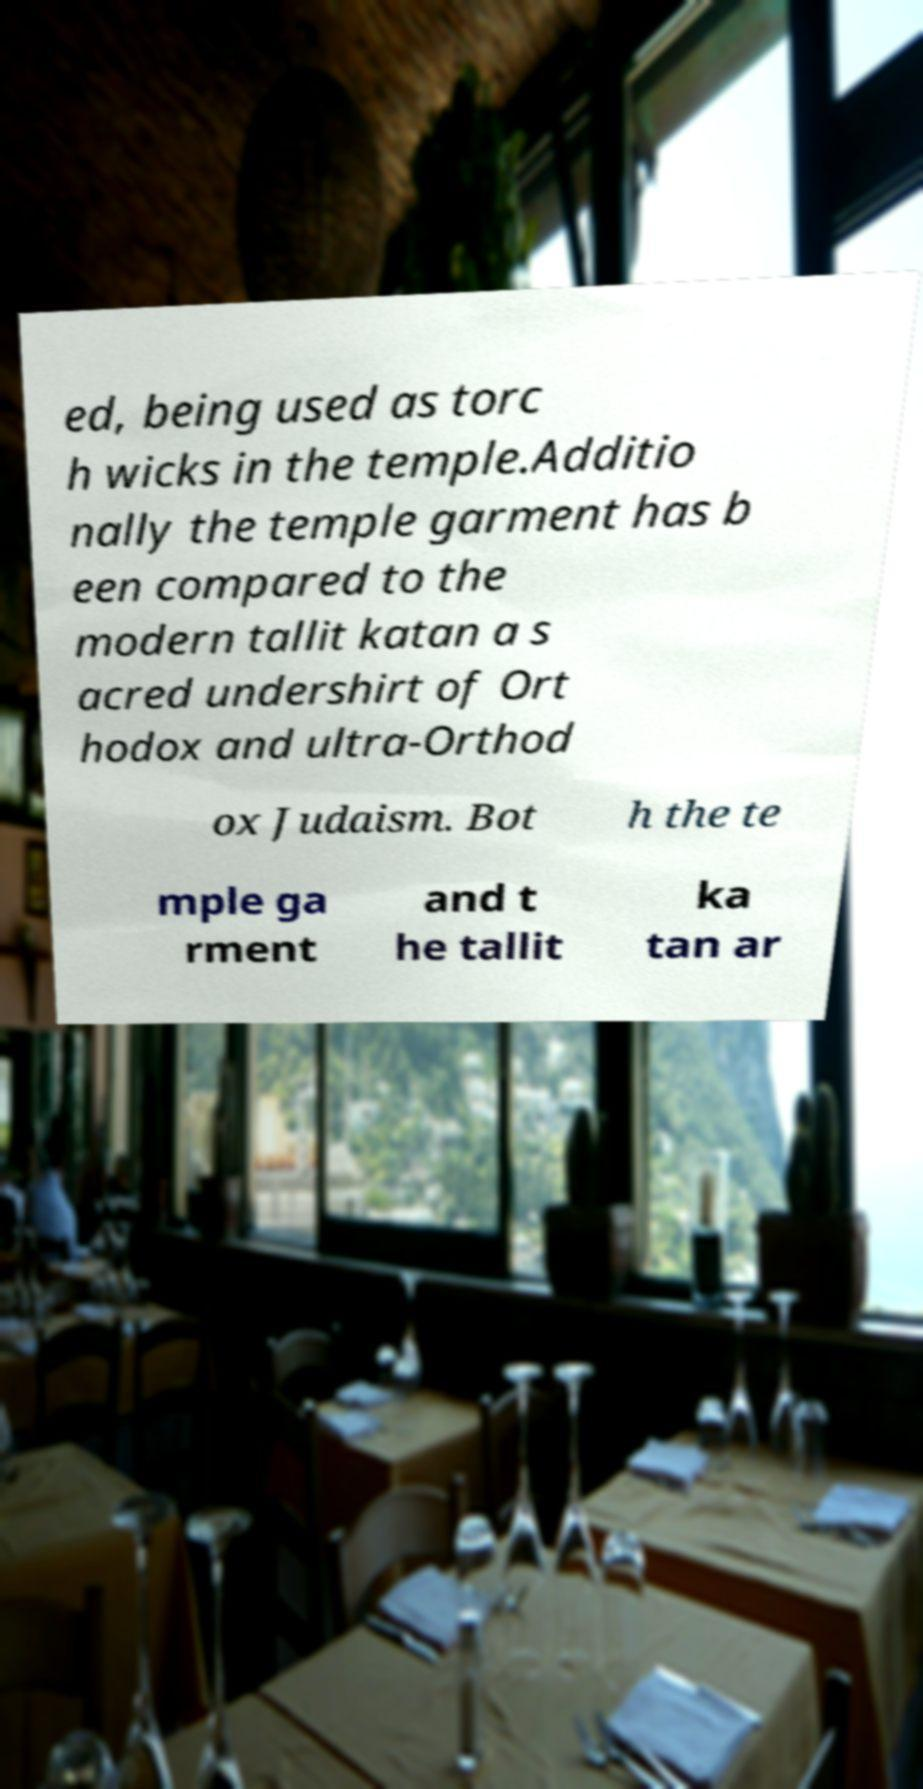There's text embedded in this image that I need extracted. Can you transcribe it verbatim? ed, being used as torc h wicks in the temple.Additio nally the temple garment has b een compared to the modern tallit katan a s acred undershirt of Ort hodox and ultra-Orthod ox Judaism. Bot h the te mple ga rment and t he tallit ka tan ar 